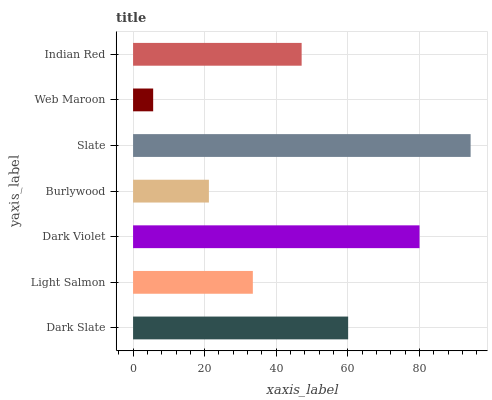Is Web Maroon the minimum?
Answer yes or no. Yes. Is Slate the maximum?
Answer yes or no. Yes. Is Light Salmon the minimum?
Answer yes or no. No. Is Light Salmon the maximum?
Answer yes or no. No. Is Dark Slate greater than Light Salmon?
Answer yes or no. Yes. Is Light Salmon less than Dark Slate?
Answer yes or no. Yes. Is Light Salmon greater than Dark Slate?
Answer yes or no. No. Is Dark Slate less than Light Salmon?
Answer yes or no. No. Is Indian Red the high median?
Answer yes or no. Yes. Is Indian Red the low median?
Answer yes or no. Yes. Is Slate the high median?
Answer yes or no. No. Is Dark Violet the low median?
Answer yes or no. No. 